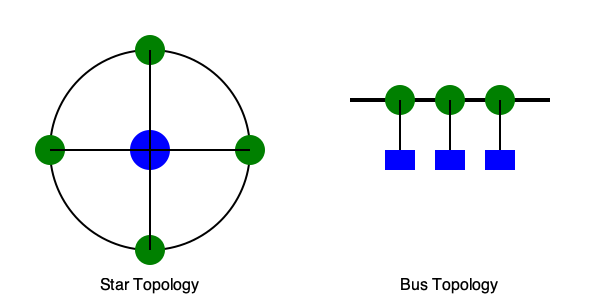A client describes their network setup as having a central device that all other devices connect to directly, with no interconnections between the peripheral devices. Which network topology diagram best represents this description? To identify the correct network topology diagram based on the given description, let's analyze the key characteristics mentioned and compare them to the topologies shown:

1. Central device: The description mentions a central device that all other devices connect to. This is a key feature of a star topology.

2. Direct connections: All devices connect directly to the central device. This is another characteristic of a star topology.

3. No interconnections between peripheral devices: The peripheral devices are not connected to each other, only to the central device. This further confirms the star topology.

4. Comparing to the diagrams:
   a. Left diagram (Star Topology):
      - Shows a central blue node with multiple green nodes connected directly to it.
      - No connections between the green nodes.
      - Matches all the described characteristics.

   b. Right diagram (Bus Topology):
      - Shows a central line (bus) with devices connected to it.
      - Doesn't have a central device that all others connect to directly.
      - Doesn't match the described characteristics.

5. Conclusion: The star topology (left diagram) best represents the described network setup.
Answer: Star Topology 